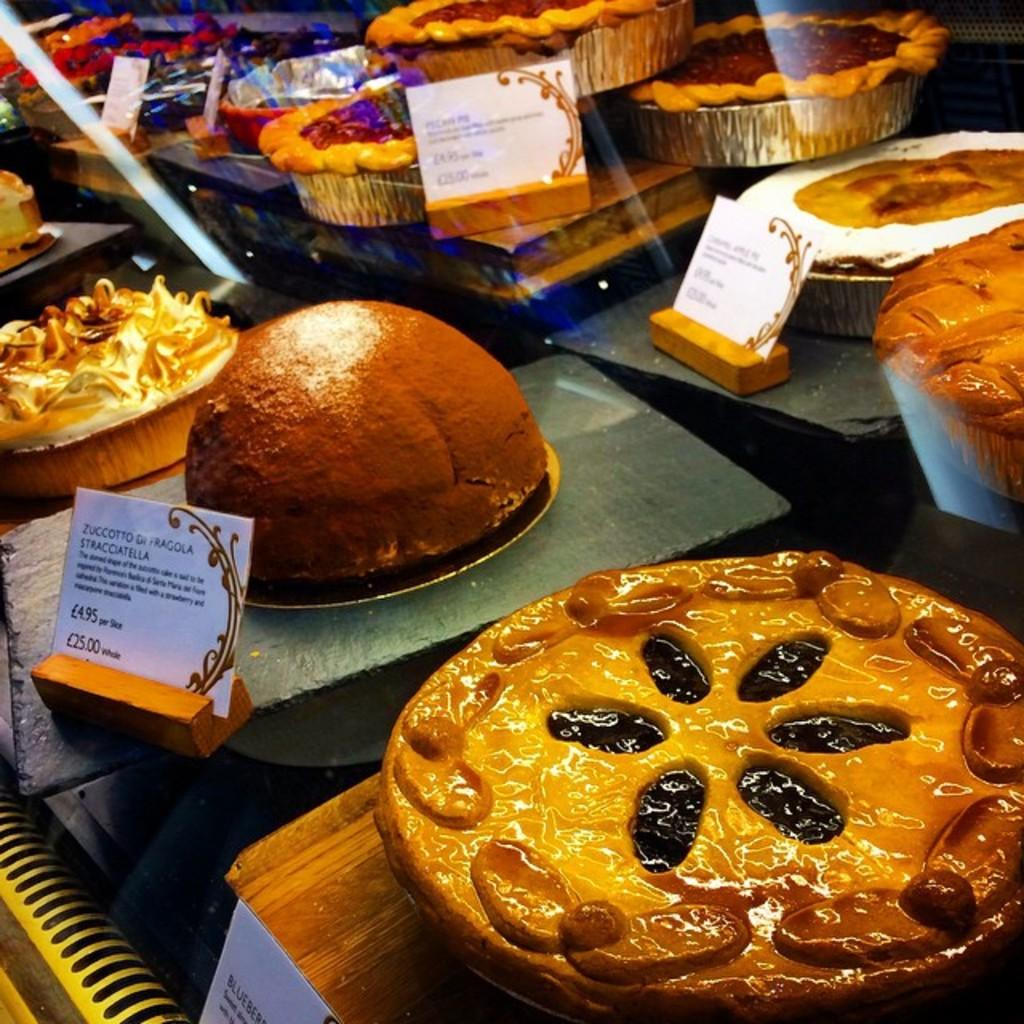What is contained within the glass in the image? Cakes are visible through the glass. How are the cakes arranged in the image? The cakes are on plates. What is the food item on a plate in the image? There is a food item on a plate, but it is not specified which one. Where are all the items located in the image? All the items are on a platform. What is the shape of the rainstorm in the image? There is no rainstorm present in the image. What is the tendency of the cakes to move around in the image? The cakes do not have a tendency to move around in the image; they are stationary on the plates. 